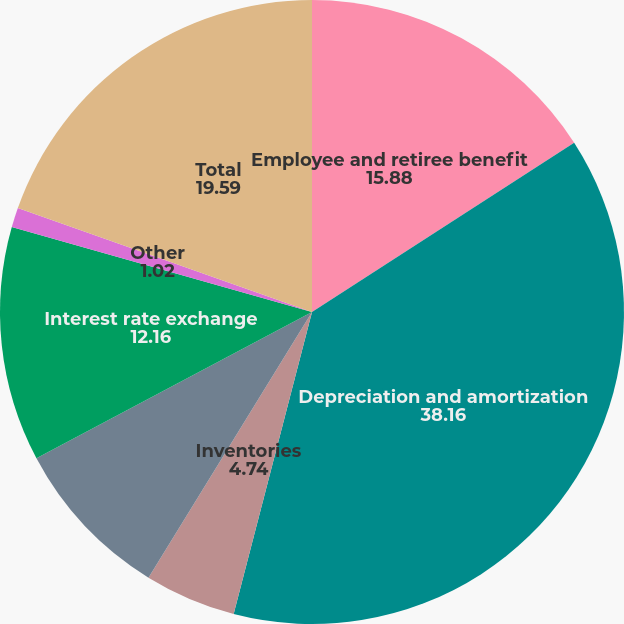<chart> <loc_0><loc_0><loc_500><loc_500><pie_chart><fcel>Employee and retiree benefit<fcel>Depreciation and amortization<fcel>Inventories<fcel>Allowances and accruals<fcel>Interest rate exchange<fcel>Other<fcel>Total<nl><fcel>15.88%<fcel>38.16%<fcel>4.74%<fcel>8.45%<fcel>12.16%<fcel>1.02%<fcel>19.59%<nl></chart> 